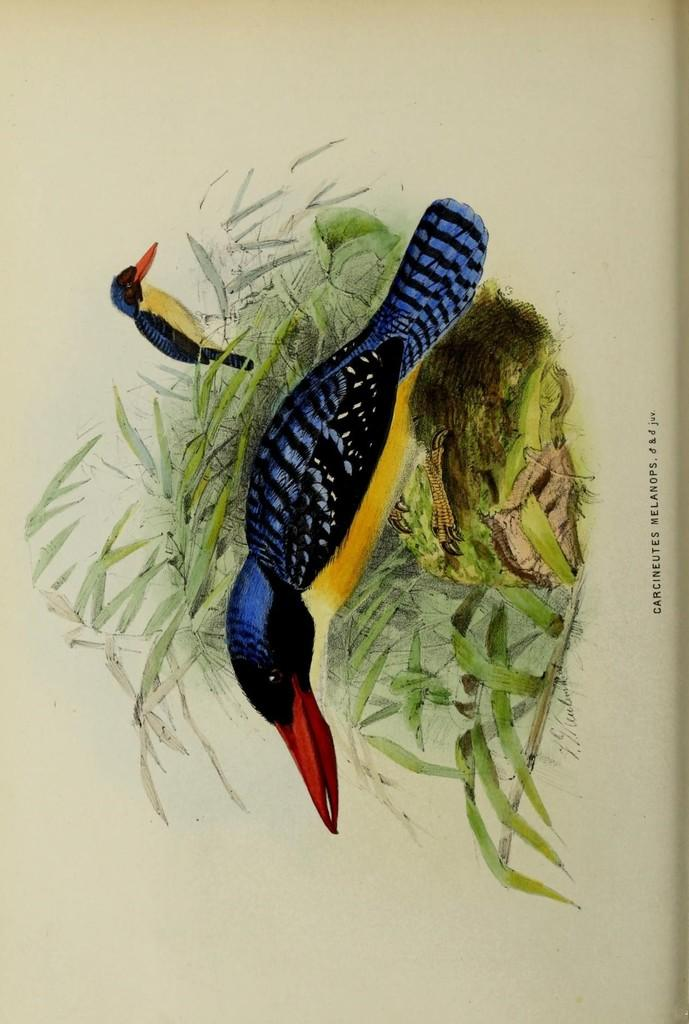What is the main subject of the painting in the image? There is a painting of two birds in the image. What other elements are present in the painting? There is a plant depicted in the painting, as well as grass on the ground. What is the text written on in the image? The text is written on a paper in the image. What is the price range of the protest depicted in the image? There is no protest depicted in the image, and therefore no price range can be determined. 